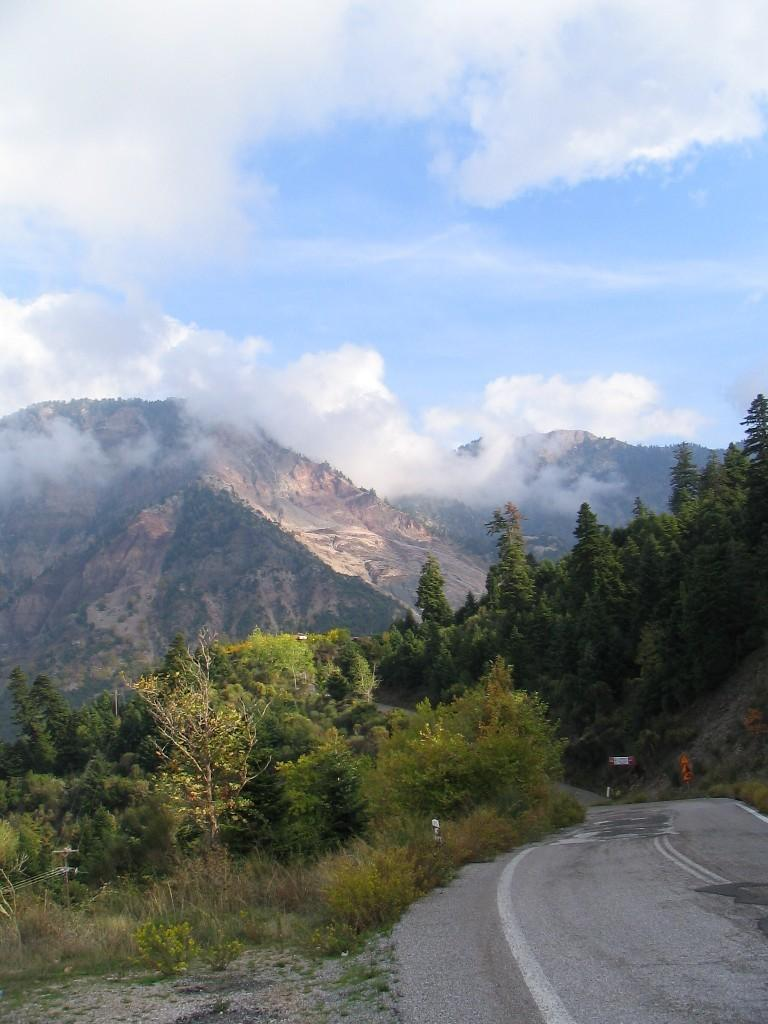What is located on the right side of the image? There is a road on the right side of the image. What type of vegetation can be seen in the image? There are trees in the image. What can be seen in the distance in the image? There are mountains in the background of the image. What is visible in the sky in the image? There are clouds in the sky. What level of education is required to climb the curve in the image? There is no curve or education mentioned in the image; it features a road, trees, mountains, and clouds. 